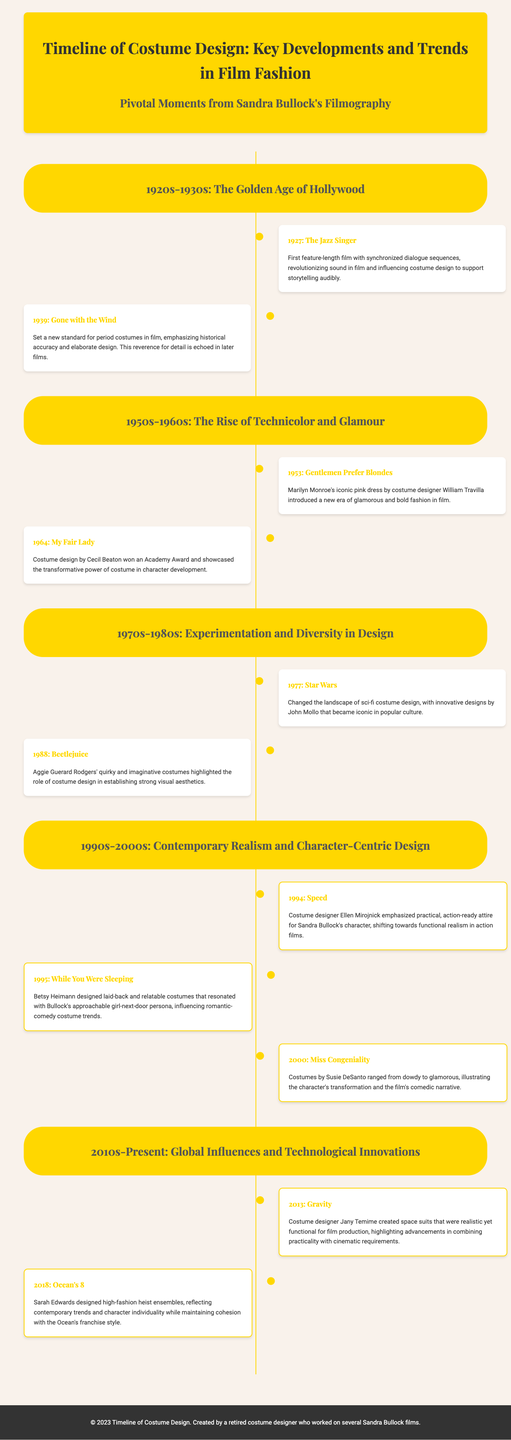what year was "The Jazz Singer" released? "The Jazz Singer" was released in 1927, as indicated in the timeline.
Answer: 1927 who designed the costumes for "While You Were Sleeping"? The costume designer for "While You Were Sleeping" was Betsy Heimann, as stated in the event description.
Answer: Betsy Heimann what significant event occurred in 1939? In 1939, "Gone with the Wind" was released, setting new standards for period costumes.
Answer: Gone with the Wind which Sandra Bullock film featured practical attire? "Speed" emphasized practical, action-ready attire for Sandra Bullock's character.
Answer: Speed what was the primary focus of costume design in "Gravity"? The focus in "Gravity" was on realistic yet functional space suits for film production.
Answer: Realistic yet functional space suits which decade introduced Technicolor in film? The 1950s-1960s era marked the rise of Technicolor and glamour in film costume design.
Answer: 1950s-1960s name the costume designer for "Miss Congeniality". The costume designer for "Miss Congeniality" was Susie DeSanto, as mentioned in the document.
Answer: Susie DeSanto what theme did "Ocean's 8" costumes reflect? The costumes designed for "Ocean's 8" reflected contemporary trends and character individuality.
Answer: Contemporary trends and character individuality which film is noted for changing sci-fi costume design? "Star Wars," released in 1977, is noted for changing the landscape of sci-fi costume design.
Answer: Star Wars 